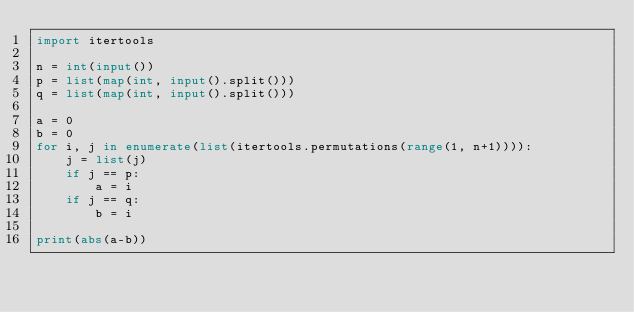<code> <loc_0><loc_0><loc_500><loc_500><_Python_>import itertools

n = int(input())
p = list(map(int, input().split()))
q = list(map(int, input().split()))

a = 0
b = 0
for i, j in enumerate(list(itertools.permutations(range(1, n+1)))):
    j = list(j)
    if j == p:
        a = i
    if j == q:
        b = i

print(abs(a-b))</code> 